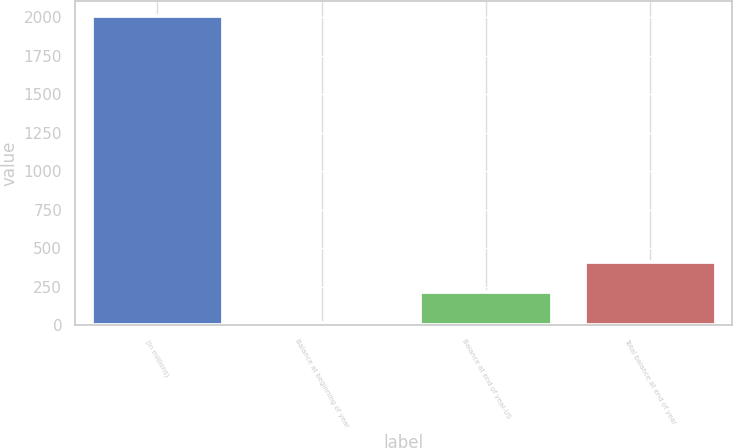Convert chart. <chart><loc_0><loc_0><loc_500><loc_500><bar_chart><fcel>(In millions)<fcel>Balance at beginning of year<fcel>Balance at end of year-US<fcel>Total balance at end of year<nl><fcel>2005<fcel>14<fcel>213.1<fcel>412.2<nl></chart> 